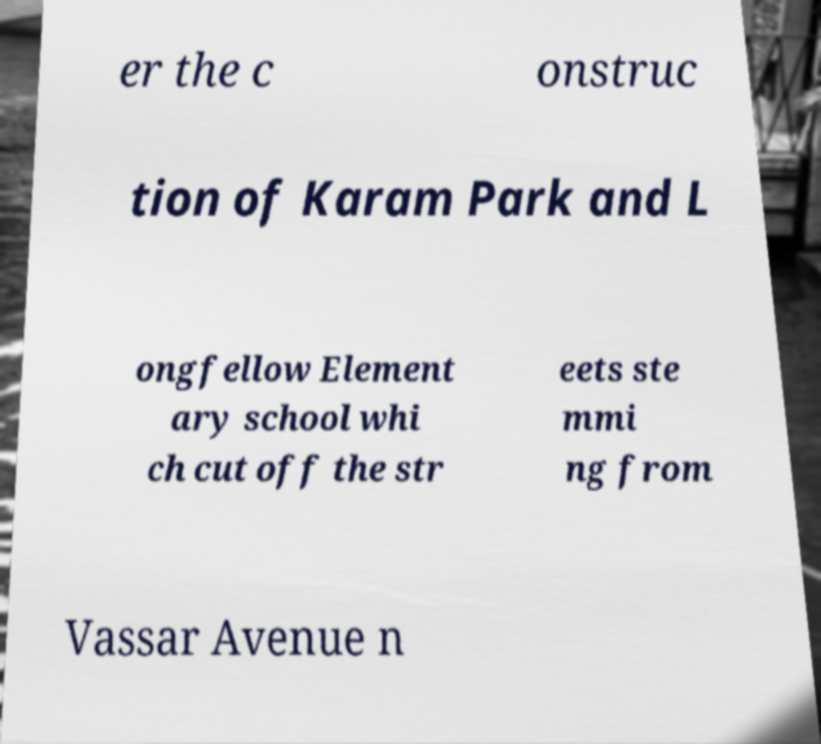Can you accurately transcribe the text from the provided image for me? er the c onstruc tion of Karam Park and L ongfellow Element ary school whi ch cut off the str eets ste mmi ng from Vassar Avenue n 